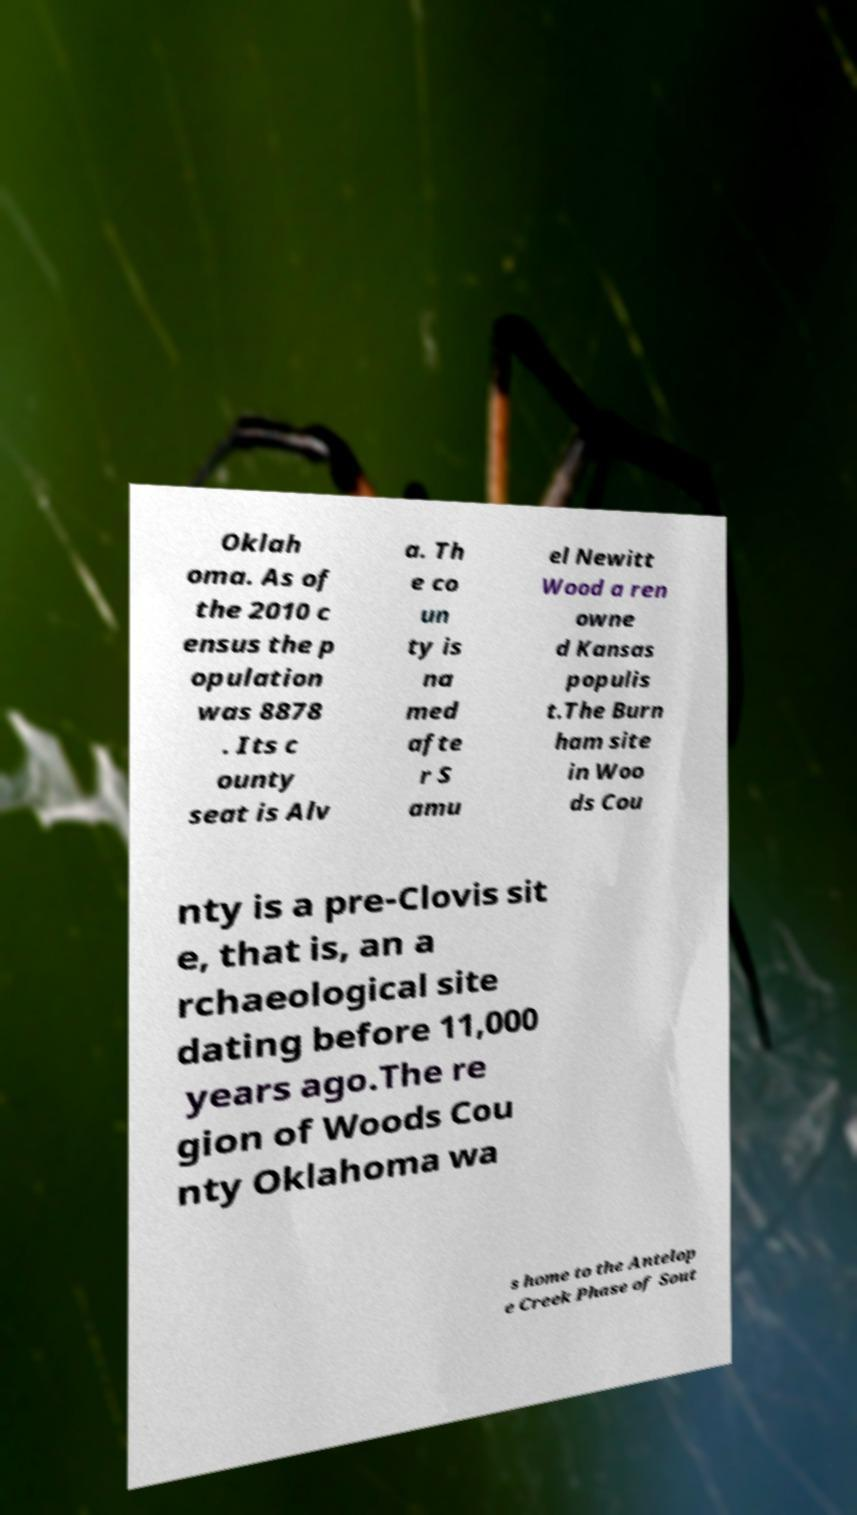What messages or text are displayed in this image? I need them in a readable, typed format. Oklah oma. As of the 2010 c ensus the p opulation was 8878 . Its c ounty seat is Alv a. Th e co un ty is na med afte r S amu el Newitt Wood a ren owne d Kansas populis t.The Burn ham site in Woo ds Cou nty is a pre-Clovis sit e, that is, an a rchaeological site dating before 11,000 years ago.The re gion of Woods Cou nty Oklahoma wa s home to the Antelop e Creek Phase of Sout 